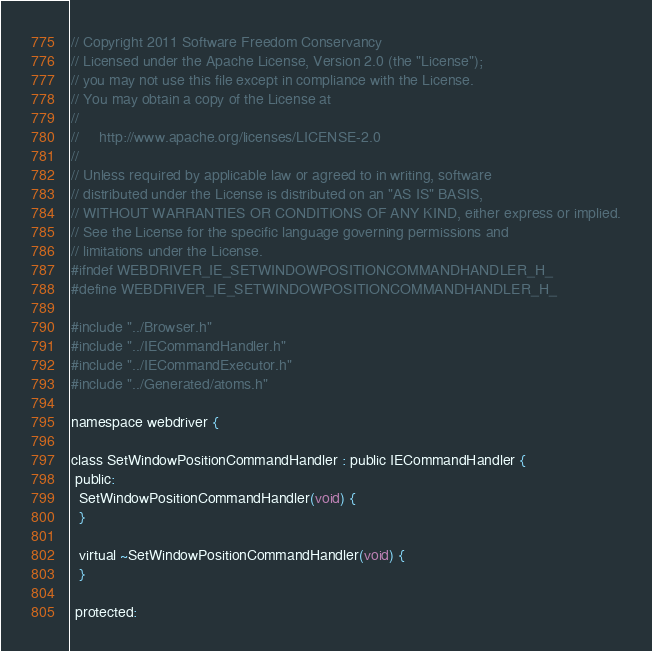Convert code to text. <code><loc_0><loc_0><loc_500><loc_500><_C_>// Copyright 2011 Software Freedom Conservancy
// Licensed under the Apache License, Version 2.0 (the "License");
// you may not use this file except in compliance with the License.
// You may obtain a copy of the License at
//
//     http://www.apache.org/licenses/LICENSE-2.0
//
// Unless required by applicable law or agreed to in writing, software
// distributed under the License is distributed on an "AS IS" BASIS,
// WITHOUT WARRANTIES OR CONDITIONS OF ANY KIND, either express or implied.
// See the License for the specific language governing permissions and
// limitations under the License.
#ifndef WEBDRIVER_IE_SETWINDOWPOSITIONCOMMANDHANDLER_H_
#define WEBDRIVER_IE_SETWINDOWPOSITIONCOMMANDHANDLER_H_

#include "../Browser.h"
#include "../IECommandHandler.h"
#include "../IECommandExecutor.h"
#include "../Generated/atoms.h"

namespace webdriver {

class SetWindowPositionCommandHandler : public IECommandHandler {
 public:
  SetWindowPositionCommandHandler(void) {
  }

  virtual ~SetWindowPositionCommandHandler(void) {
  }

 protected:</code> 